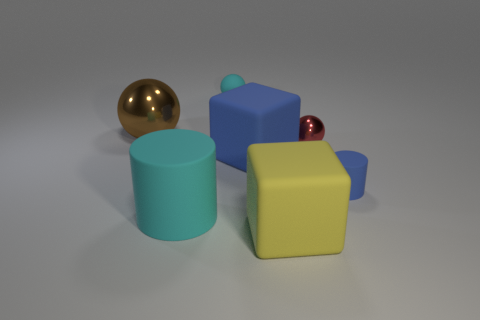Add 2 brown shiny objects. How many objects exist? 9 Subtract all cylinders. How many objects are left? 5 Add 6 tiny blocks. How many tiny blocks exist? 6 Subtract 1 brown balls. How many objects are left? 6 Subtract all small yellow shiny cylinders. Subtract all big rubber cylinders. How many objects are left? 6 Add 3 small blue cylinders. How many small blue cylinders are left? 4 